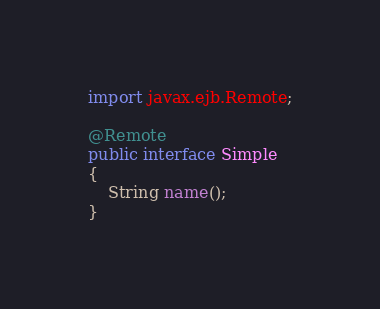Convert code to text. <code><loc_0><loc_0><loc_500><loc_500><_Java_>
import javax.ejb.Remote;

@Remote
public interface Simple
{
    String name();
}
</code> 